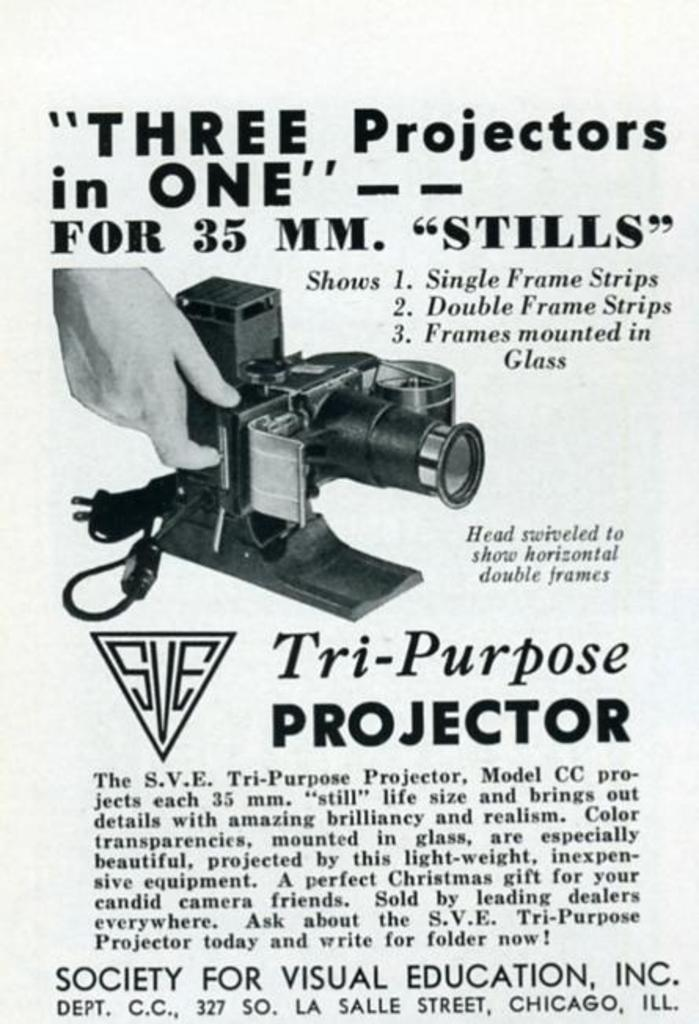<image>
Relay a brief, clear account of the picture shown. advertisement for sve tri-purpose projector for 35mm stills 